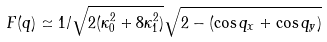Convert formula to latex. <formula><loc_0><loc_0><loc_500><loc_500>F ( q ) \simeq 1 / \sqrt { 2 ( \kappa _ { 0 } ^ { 2 } + 8 \kappa _ { 1 } ^ { 2 } ) } \sqrt { 2 - ( \cos q _ { x } + \cos q _ { y } ) }</formula> 